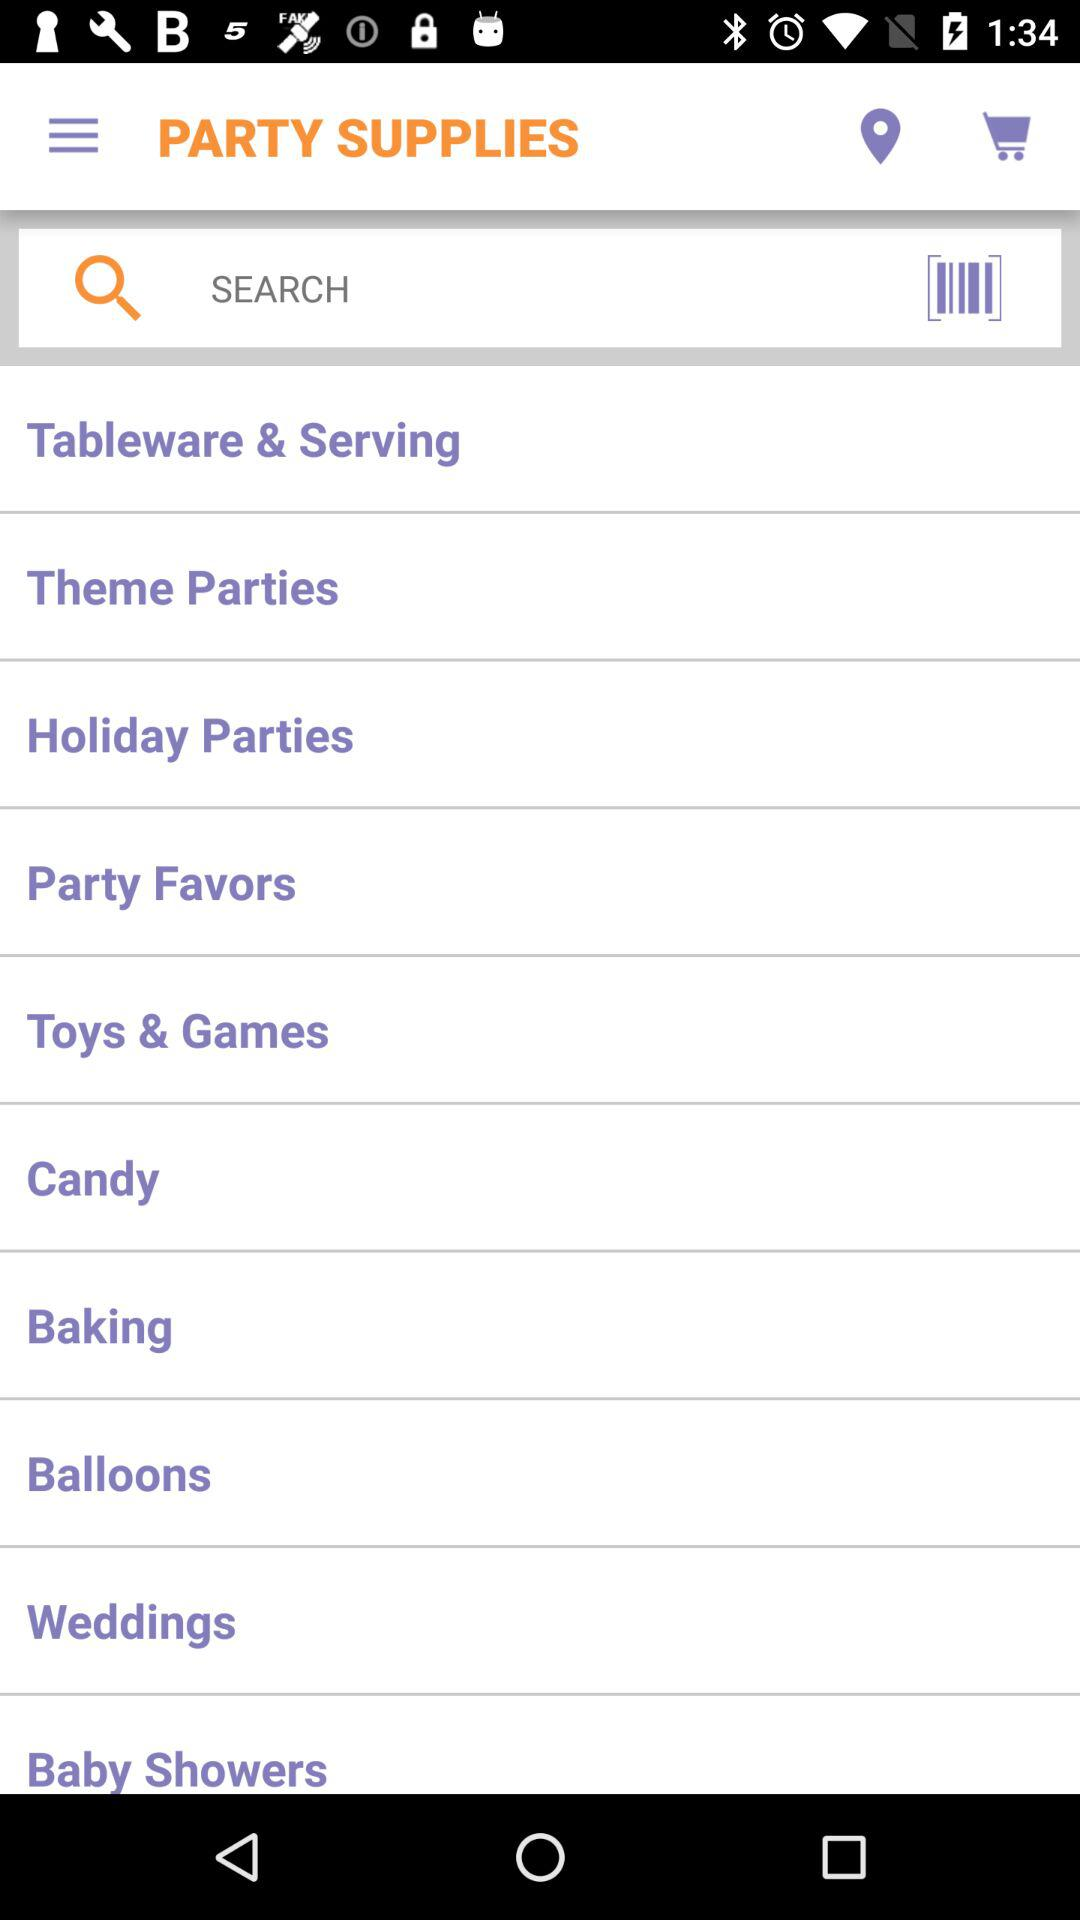What are the options in "PARTY SUPPLIES"? The options in "PARTY SUPPLIES" are "Tableware & Serving", "Theme Parties", "Holiday Parties", "Party Favors", "Toys & Games", "Candy", "Baking", "Balloons", "Weddings" and "Baby Showers". 